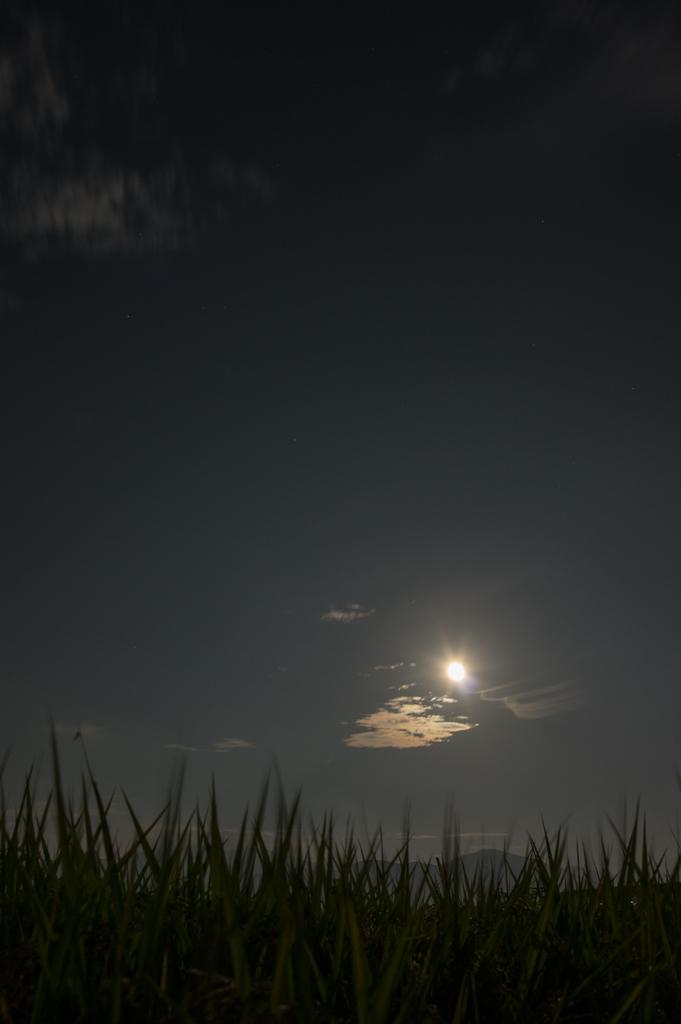What type of vegetation can be seen in the image? There is grass in the image. What can be seen in the sky in the image? There are clouds in the image. What celestial body is visible in the image? The sun is visible in the image. What type of apples can be seen growing on the grass in the image? There are no apples present in the image; it only features grass. What substance is being used to run on the grass in the image? There is no substance or activity of running depicted in the image; it only shows grass, clouds, and the sun. 